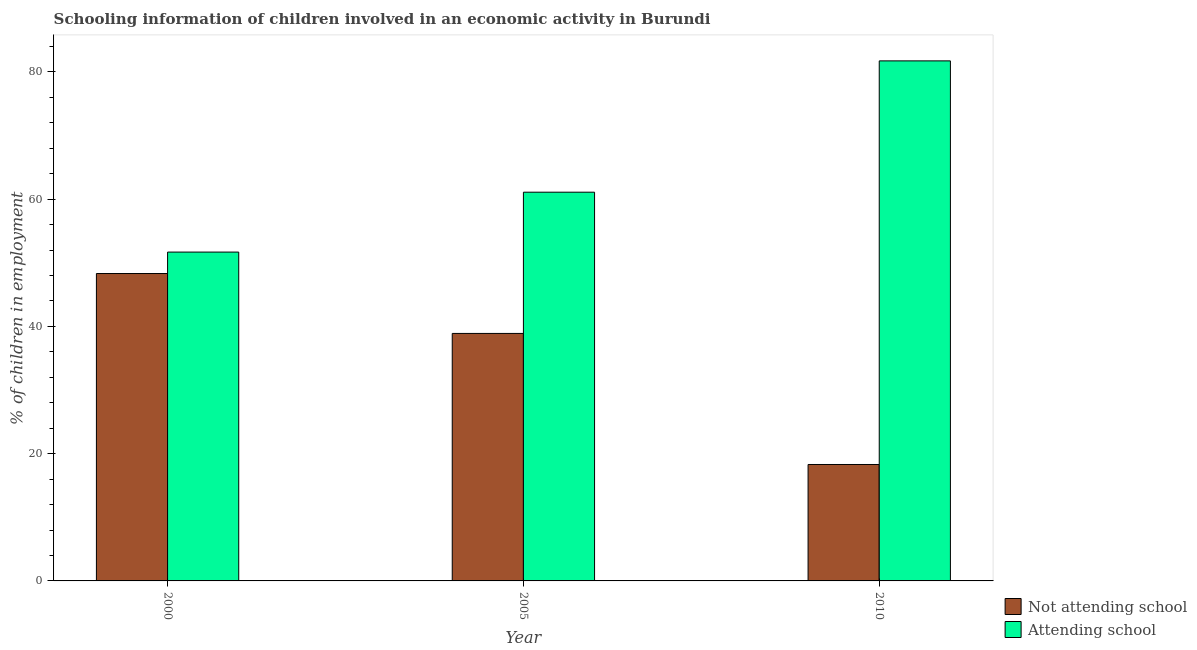How many bars are there on the 3rd tick from the left?
Offer a terse response. 2. In how many cases, is the number of bars for a given year not equal to the number of legend labels?
Your answer should be very brief. 0. What is the percentage of employed children who are not attending school in 2005?
Keep it short and to the point. 38.9. Across all years, what is the maximum percentage of employed children who are not attending school?
Offer a very short reply. 48.32. Across all years, what is the minimum percentage of employed children who are attending school?
Provide a succinct answer. 51.68. In which year was the percentage of employed children who are not attending school maximum?
Your response must be concise. 2000. What is the total percentage of employed children who are not attending school in the graph?
Keep it short and to the point. 105.52. What is the difference between the percentage of employed children who are not attending school in 2000 and that in 2005?
Offer a terse response. 9.42. What is the difference between the percentage of employed children who are not attending school in 2005 and the percentage of employed children who are attending school in 2010?
Your response must be concise. 20.6. What is the average percentage of employed children who are attending school per year?
Give a very brief answer. 64.84. In the year 2010, what is the difference between the percentage of employed children who are attending school and percentage of employed children who are not attending school?
Offer a very short reply. 0. What is the ratio of the percentage of employed children who are not attending school in 2000 to that in 2010?
Give a very brief answer. 2.64. Is the percentage of employed children who are attending school in 2000 less than that in 2005?
Provide a succinct answer. Yes. What is the difference between the highest and the second highest percentage of employed children who are attending school?
Your answer should be compact. 20.64. What is the difference between the highest and the lowest percentage of employed children who are not attending school?
Your answer should be very brief. 30.02. What does the 2nd bar from the left in 2010 represents?
Ensure brevity in your answer.  Attending school. What does the 1st bar from the right in 2010 represents?
Your answer should be compact. Attending school. How many bars are there?
Offer a terse response. 6. How many years are there in the graph?
Ensure brevity in your answer.  3. Where does the legend appear in the graph?
Ensure brevity in your answer.  Bottom right. What is the title of the graph?
Give a very brief answer. Schooling information of children involved in an economic activity in Burundi. Does "Techinal cooperation" appear as one of the legend labels in the graph?
Make the answer very short. No. What is the label or title of the Y-axis?
Make the answer very short. % of children in employment. What is the % of children in employment of Not attending school in 2000?
Provide a short and direct response. 48.32. What is the % of children in employment in Attending school in 2000?
Your answer should be compact. 51.68. What is the % of children in employment of Not attending school in 2005?
Ensure brevity in your answer.  38.9. What is the % of children in employment in Attending school in 2005?
Make the answer very short. 61.1. What is the % of children in employment of Not attending school in 2010?
Ensure brevity in your answer.  18.3. What is the % of children in employment in Attending school in 2010?
Keep it short and to the point. 81.74. Across all years, what is the maximum % of children in employment in Not attending school?
Offer a very short reply. 48.32. Across all years, what is the maximum % of children in employment in Attending school?
Provide a succinct answer. 81.74. Across all years, what is the minimum % of children in employment of Not attending school?
Provide a succinct answer. 18.3. Across all years, what is the minimum % of children in employment in Attending school?
Your answer should be very brief. 51.68. What is the total % of children in employment of Not attending school in the graph?
Your answer should be very brief. 105.52. What is the total % of children in employment of Attending school in the graph?
Provide a short and direct response. 194.52. What is the difference between the % of children in employment of Not attending school in 2000 and that in 2005?
Keep it short and to the point. 9.42. What is the difference between the % of children in employment of Attending school in 2000 and that in 2005?
Give a very brief answer. -9.42. What is the difference between the % of children in employment of Not attending school in 2000 and that in 2010?
Ensure brevity in your answer.  30.02. What is the difference between the % of children in employment in Attending school in 2000 and that in 2010?
Ensure brevity in your answer.  -30.05. What is the difference between the % of children in employment in Not attending school in 2005 and that in 2010?
Your answer should be very brief. 20.6. What is the difference between the % of children in employment in Attending school in 2005 and that in 2010?
Give a very brief answer. -20.64. What is the difference between the % of children in employment in Not attending school in 2000 and the % of children in employment in Attending school in 2005?
Offer a terse response. -12.78. What is the difference between the % of children in employment of Not attending school in 2000 and the % of children in employment of Attending school in 2010?
Provide a succinct answer. -33.42. What is the difference between the % of children in employment of Not attending school in 2005 and the % of children in employment of Attending school in 2010?
Give a very brief answer. -42.84. What is the average % of children in employment of Not attending school per year?
Provide a short and direct response. 35.17. What is the average % of children in employment of Attending school per year?
Give a very brief answer. 64.84. In the year 2000, what is the difference between the % of children in employment of Not attending school and % of children in employment of Attending school?
Your answer should be very brief. -3.37. In the year 2005, what is the difference between the % of children in employment in Not attending school and % of children in employment in Attending school?
Keep it short and to the point. -22.2. In the year 2010, what is the difference between the % of children in employment of Not attending school and % of children in employment of Attending school?
Give a very brief answer. -63.44. What is the ratio of the % of children in employment of Not attending school in 2000 to that in 2005?
Offer a very short reply. 1.24. What is the ratio of the % of children in employment of Attending school in 2000 to that in 2005?
Keep it short and to the point. 0.85. What is the ratio of the % of children in employment of Not attending school in 2000 to that in 2010?
Offer a very short reply. 2.64. What is the ratio of the % of children in employment in Attending school in 2000 to that in 2010?
Your response must be concise. 0.63. What is the ratio of the % of children in employment of Not attending school in 2005 to that in 2010?
Provide a succinct answer. 2.13. What is the ratio of the % of children in employment of Attending school in 2005 to that in 2010?
Offer a very short reply. 0.75. What is the difference between the highest and the second highest % of children in employment in Not attending school?
Provide a short and direct response. 9.42. What is the difference between the highest and the second highest % of children in employment of Attending school?
Provide a succinct answer. 20.64. What is the difference between the highest and the lowest % of children in employment in Not attending school?
Offer a terse response. 30.02. What is the difference between the highest and the lowest % of children in employment of Attending school?
Give a very brief answer. 30.05. 